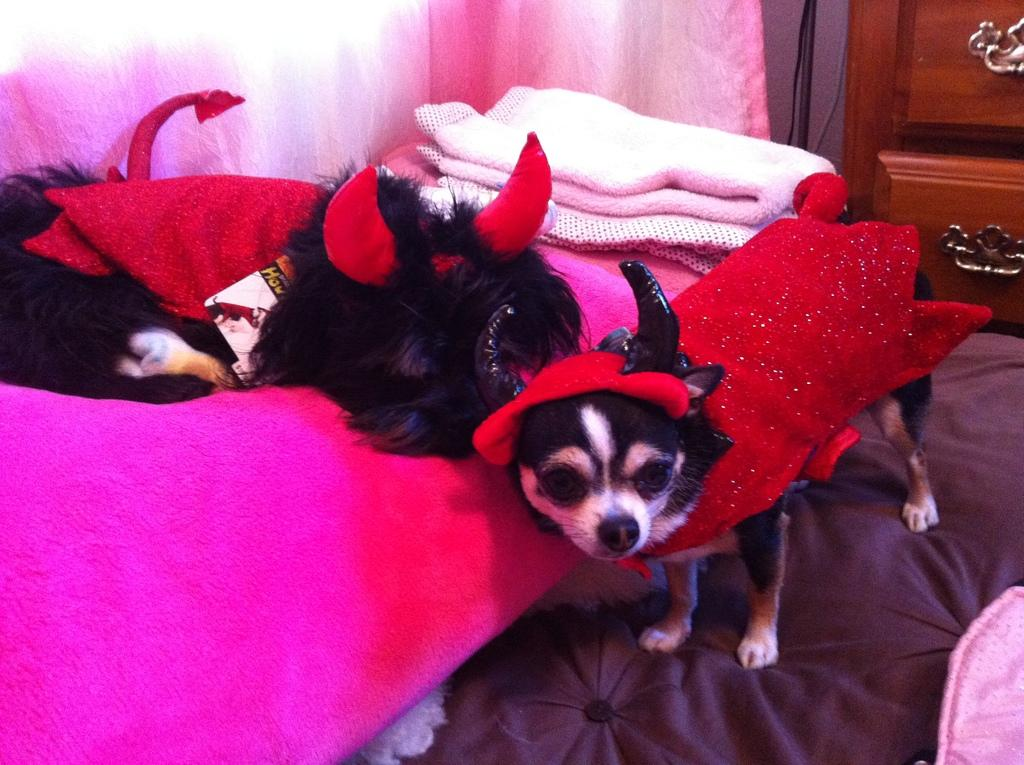What type of animals are in the image? There are dogs in the image. What are the dogs wearing? The dogs are wearing dresses. What can be seen in the background of the image? There are quilts, a cupboard, and cables in the background of the image. What type of card is being used to balance the dogs in the image? There is no card present in the image, and the dogs are not being balanced by any object. 